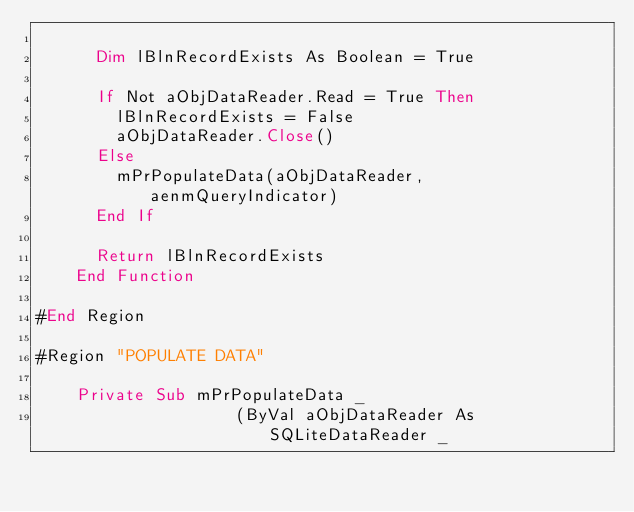<code> <loc_0><loc_0><loc_500><loc_500><_VisualBasic_>
      Dim lBlnRecordExists As Boolean = True

      If Not aObjDataReader.Read = True Then
        lBlnRecordExists = False
        aObjDataReader.Close()
      Else
        mPrPopulateData(aObjDataReader, aenmQueryIndicator)
      End If

      Return lBlnRecordExists
    End Function

#End Region

#Region "POPULATE DATA"

    Private Sub mPrPopulateData _
                    (ByVal aObjDataReader As SQLiteDataReader _</code> 